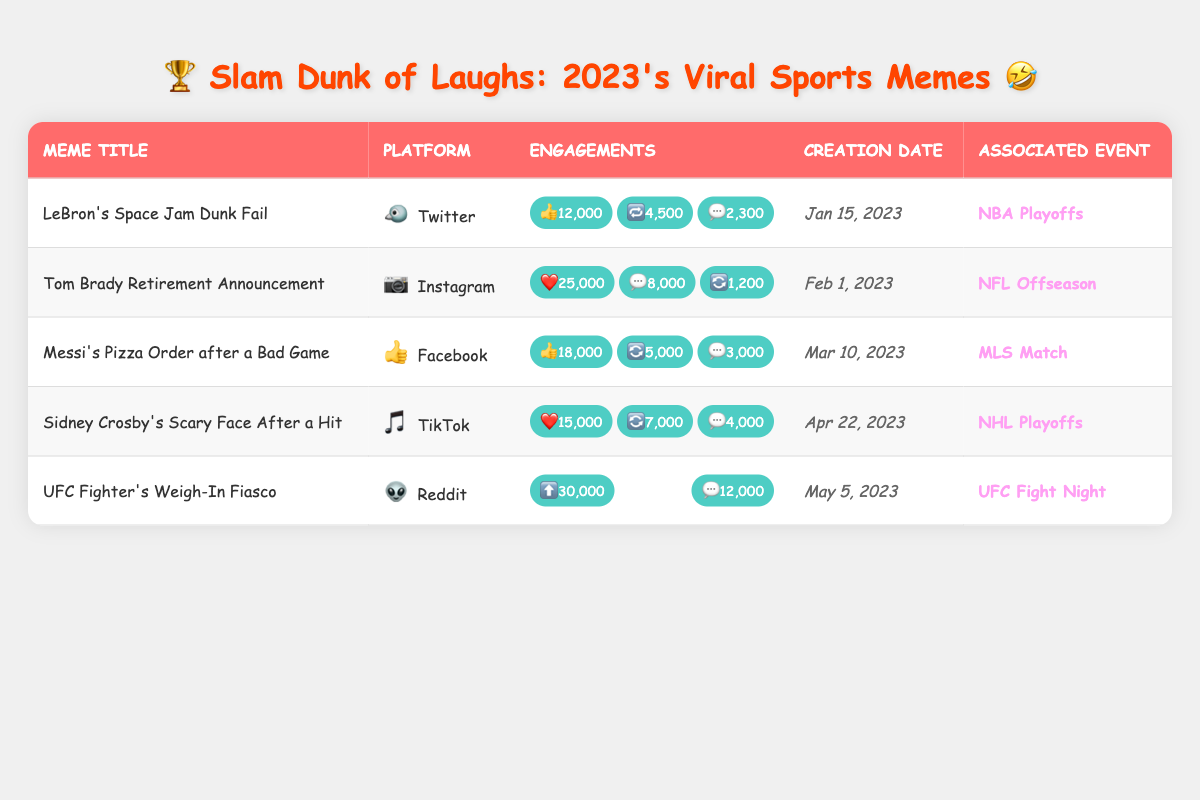What is the total number of likes for all memes? To find the total number of likes, we add the likes for each meme: 12,000 (LeBron) + 25,000 (Tom Brady) + 18,000 (Messi) + 15,000 (Crosby) + 30,000 (UFC) = 100,000.
Answer: 100,000 Which meme has the highest engagement on Reddit? The only Reddit meme is "UFC Fighter's Weigh-In Fiasco," with 30,000 upvotes and 12,000 comments. To determine the highest engagement, we consider both types of engagements: 30,000 (upvotes) is the highest.
Answer: UFC Fighter's Weigh-In Fiasco Is there a meme that has more comments than likes? For each meme, we compare comments and likes: LeBron (2,300 < 12,000), Tom Brady (8,000 < 25,000), Messi (3,000 < 18,000), Crosby (4,000 < 15,000), and UFC (12,000 > 30,000). No meme has more comments than likes.
Answer: No What platform had the least engagement overall based on likes, shares, and comments? We total the engagements for each meme: LeBron (19,800), Brady (34,200), Messi (26,000), Crosby (26,000), UFC (42,000). The least total engagements are LeBron's 19,800.
Answer: Twitter How many total engagements did the meme "Tom Brady Retirement Announcement" generate? For Tom Brady, total engagements are likes (25,000), comments (8,000), and shares (1,200). Summing these gives us 25,000 + 8,000 + 1,200 = 34,200.
Answer: 34,200 Which sport-related event had the most engagement? We look at total engagements for each meme: NBA Playoffs (19,800), NFL Offseason (34,200), MLS Match (26,000), NHL Playoffs (26,000), UFC Fight Night (42,000). The event with the most engagement is UFC Fight Night.
Answer: UFC Fight Night Did any memes relate to the NHL Playoffs? Yes, we verify the associated events for each meme: LeBron (NBA Playoffs), Brady (NFL Offseason), Messi (MLS Match), Crosby (NHL Playoffs), and UFC (UFC Fight Night). "Sidney Crosby's Scary Face After a Hit" relates to the NHL Playoffs.
Answer: Yes What is the average number of shares across all platforms? We gather shares from the memes: 4,500 (LeBron) + 1,200 (Tom Brady) + 5,000 (Messi) + 7,000 (Crosby) + 30,000 (UFC) = 47,700 shares. There are four memes with share data (excluding Twitter). Therefore, the average is 47,700 / 4 = 11,925.
Answer: 11,925 